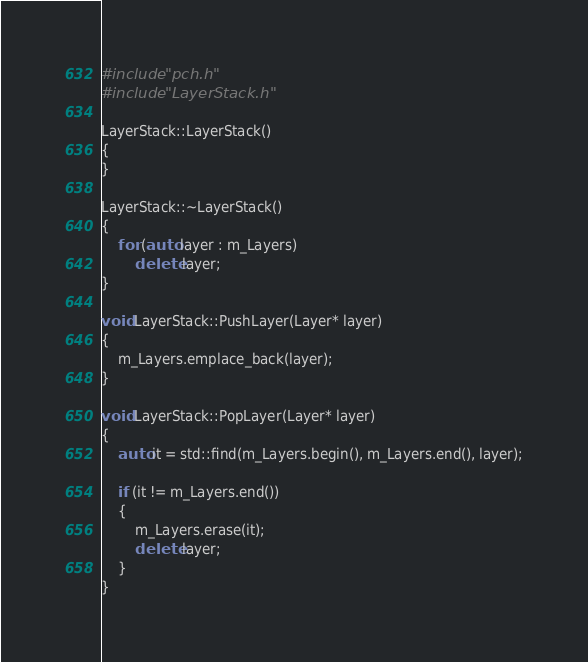Convert code to text. <code><loc_0><loc_0><loc_500><loc_500><_C++_>#include "pch.h"
#include "LayerStack.h"

LayerStack::LayerStack()
{
}

LayerStack::~LayerStack()
{
	for (auto layer : m_Layers)
		delete layer;
}

void LayerStack::PushLayer(Layer* layer)
{
	m_Layers.emplace_back(layer);
}

void LayerStack::PopLayer(Layer* layer)
{
	auto it = std::find(m_Layers.begin(), m_Layers.end(), layer);

	if (it != m_Layers.end())
	{
		m_Layers.erase(it);
		delete layer;
	}
}
</code> 